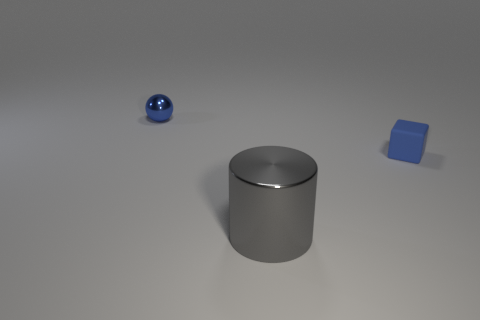Add 1 blue matte objects. How many objects exist? 4 Subtract all balls. How many objects are left? 2 Add 2 big gray cylinders. How many big gray cylinders are left? 3 Add 1 matte things. How many matte things exist? 2 Subtract 0 purple spheres. How many objects are left? 3 Subtract all purple spheres. Subtract all blue things. How many objects are left? 1 